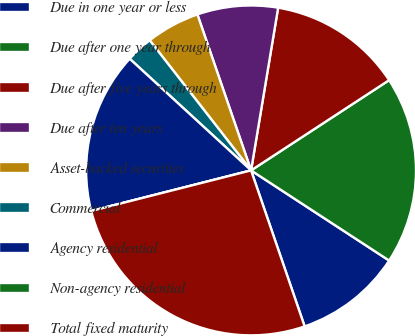<chart> <loc_0><loc_0><loc_500><loc_500><pie_chart><fcel>Due in one year or less<fcel>Due after one year through<fcel>Due after five years through<fcel>Due after ten years<fcel>Asset-backed securities<fcel>Commercial<fcel>Agency residential<fcel>Non-agency residential<fcel>Total fixed maturity<nl><fcel>10.53%<fcel>18.42%<fcel>13.16%<fcel>7.9%<fcel>5.26%<fcel>2.63%<fcel>15.79%<fcel>0.0%<fcel>26.31%<nl></chart> 